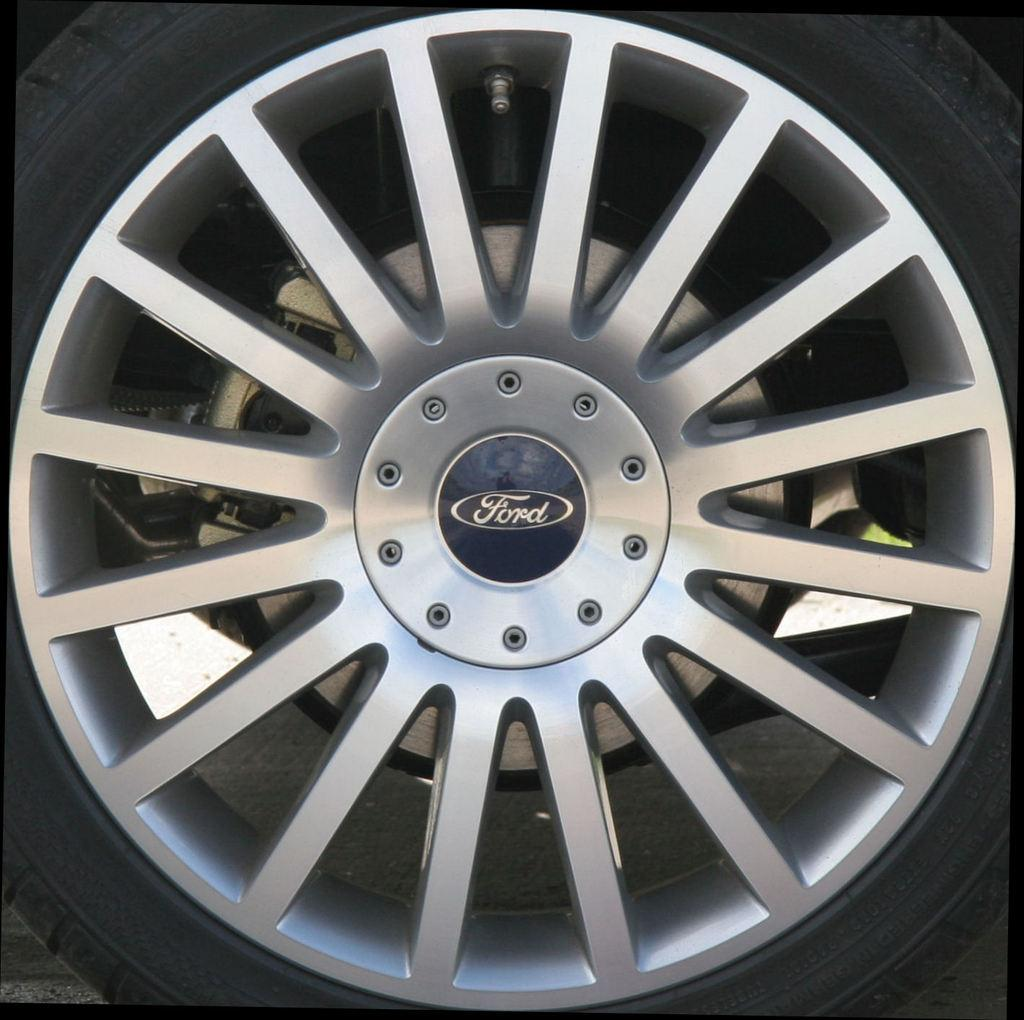What object can be seen in the image? There is a wheel in the image. What type of throat problem is depicted in the image? There is no throat problem depicted in the image; it features a wheel. Can you hear a whistle in the image? There is no whistle present in the image; it features a wheel. 